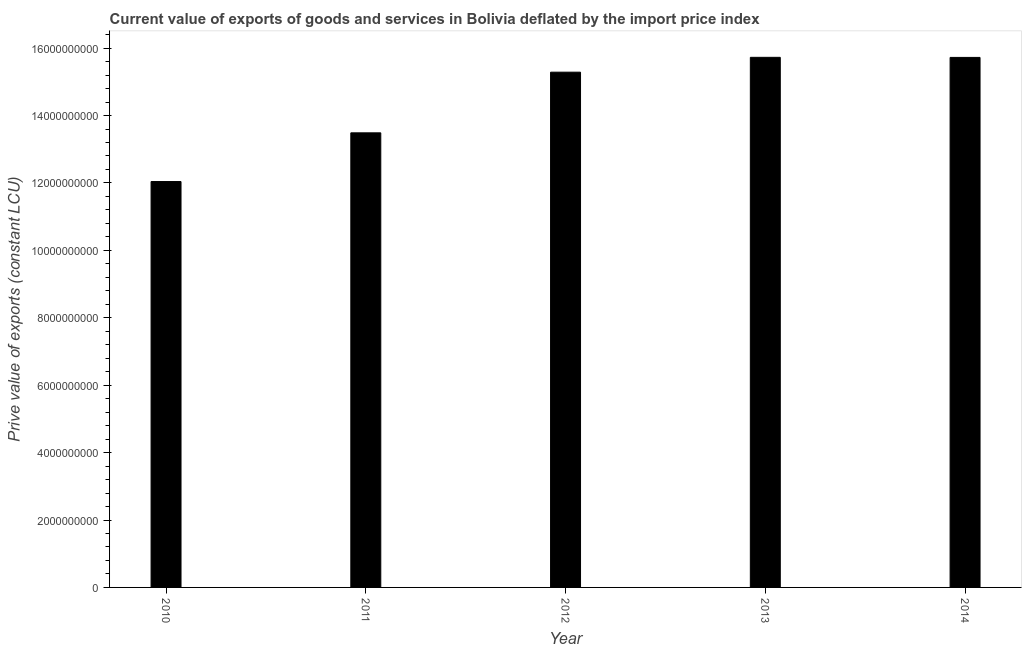Does the graph contain any zero values?
Your answer should be compact. No. Does the graph contain grids?
Make the answer very short. No. What is the title of the graph?
Make the answer very short. Current value of exports of goods and services in Bolivia deflated by the import price index. What is the label or title of the Y-axis?
Provide a succinct answer. Prive value of exports (constant LCU). What is the price value of exports in 2014?
Your answer should be very brief. 1.57e+1. Across all years, what is the maximum price value of exports?
Provide a short and direct response. 1.57e+1. Across all years, what is the minimum price value of exports?
Your response must be concise. 1.20e+1. What is the sum of the price value of exports?
Your response must be concise. 7.23e+1. What is the difference between the price value of exports in 2010 and 2014?
Your answer should be very brief. -3.68e+09. What is the average price value of exports per year?
Your response must be concise. 1.45e+1. What is the median price value of exports?
Ensure brevity in your answer.  1.53e+1. Do a majority of the years between 2014 and 2012 (inclusive) have price value of exports greater than 1600000000 LCU?
Provide a short and direct response. Yes. What is the ratio of the price value of exports in 2010 to that in 2014?
Offer a terse response. 0.77. Is the price value of exports in 2011 less than that in 2013?
Give a very brief answer. Yes. Is the difference between the price value of exports in 2010 and 2013 greater than the difference between any two years?
Make the answer very short. Yes. What is the difference between the highest and the second highest price value of exports?
Provide a short and direct response. 2.36e+06. What is the difference between the highest and the lowest price value of exports?
Your response must be concise. 3.69e+09. In how many years, is the price value of exports greater than the average price value of exports taken over all years?
Provide a short and direct response. 3. Are all the bars in the graph horizontal?
Offer a very short reply. No. How many years are there in the graph?
Your answer should be compact. 5. Are the values on the major ticks of Y-axis written in scientific E-notation?
Provide a short and direct response. No. What is the Prive value of exports (constant LCU) in 2010?
Make the answer very short. 1.20e+1. What is the Prive value of exports (constant LCU) of 2011?
Offer a terse response. 1.35e+1. What is the Prive value of exports (constant LCU) in 2012?
Your answer should be compact. 1.53e+1. What is the Prive value of exports (constant LCU) in 2013?
Offer a terse response. 1.57e+1. What is the Prive value of exports (constant LCU) in 2014?
Offer a terse response. 1.57e+1. What is the difference between the Prive value of exports (constant LCU) in 2010 and 2011?
Provide a succinct answer. -1.44e+09. What is the difference between the Prive value of exports (constant LCU) in 2010 and 2012?
Your answer should be compact. -3.24e+09. What is the difference between the Prive value of exports (constant LCU) in 2010 and 2013?
Your answer should be very brief. -3.69e+09. What is the difference between the Prive value of exports (constant LCU) in 2010 and 2014?
Keep it short and to the point. -3.68e+09. What is the difference between the Prive value of exports (constant LCU) in 2011 and 2012?
Make the answer very short. -1.80e+09. What is the difference between the Prive value of exports (constant LCU) in 2011 and 2013?
Offer a very short reply. -2.24e+09. What is the difference between the Prive value of exports (constant LCU) in 2011 and 2014?
Your answer should be very brief. -2.24e+09. What is the difference between the Prive value of exports (constant LCU) in 2012 and 2013?
Offer a very short reply. -4.41e+08. What is the difference between the Prive value of exports (constant LCU) in 2012 and 2014?
Make the answer very short. -4.38e+08. What is the difference between the Prive value of exports (constant LCU) in 2013 and 2014?
Provide a succinct answer. 2.36e+06. What is the ratio of the Prive value of exports (constant LCU) in 2010 to that in 2011?
Provide a succinct answer. 0.89. What is the ratio of the Prive value of exports (constant LCU) in 2010 to that in 2012?
Offer a terse response. 0.79. What is the ratio of the Prive value of exports (constant LCU) in 2010 to that in 2013?
Your answer should be very brief. 0.77. What is the ratio of the Prive value of exports (constant LCU) in 2010 to that in 2014?
Provide a succinct answer. 0.77. What is the ratio of the Prive value of exports (constant LCU) in 2011 to that in 2012?
Your answer should be compact. 0.88. What is the ratio of the Prive value of exports (constant LCU) in 2011 to that in 2013?
Offer a very short reply. 0.86. What is the ratio of the Prive value of exports (constant LCU) in 2011 to that in 2014?
Keep it short and to the point. 0.86. What is the ratio of the Prive value of exports (constant LCU) in 2012 to that in 2013?
Offer a very short reply. 0.97. What is the ratio of the Prive value of exports (constant LCU) in 2012 to that in 2014?
Give a very brief answer. 0.97. 